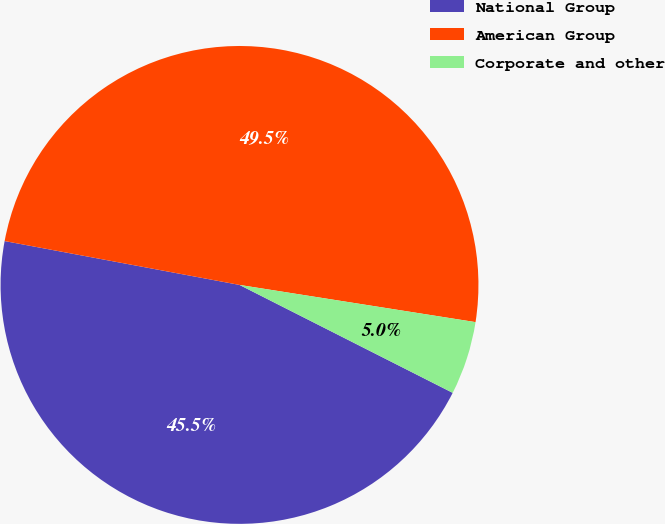<chart> <loc_0><loc_0><loc_500><loc_500><pie_chart><fcel>National Group<fcel>American Group<fcel>Corporate and other<nl><fcel>45.48%<fcel>49.55%<fcel>4.97%<nl></chart> 